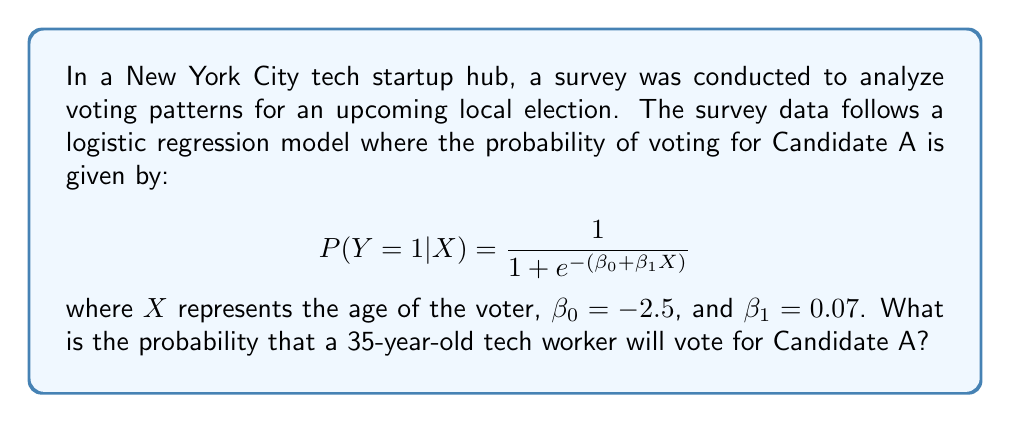Provide a solution to this math problem. To solve this problem, we'll follow these steps:

1. Identify the given information:
   $\beta_0 = -2.5$
   $\beta_1 = 0.07$
   $X = 35$ (age of the voter)

2. Substitute these values into the logistic regression equation:
   $$P(Y=1|X) = \frac{1}{1 + e^{-(\beta_0 + \beta_1X)}}$$
   $$P(Y=1|X=35) = \frac{1}{1 + e^{-(-2.5 + 0.07 \cdot 35)}}$$

3. Simplify the expression inside the exponential:
   $$P(Y=1|X=35) = \frac{1}{1 + e^{-(0.07 \cdot 35 - 2.5)}}$$
   $$P(Y=1|X=35) = \frac{1}{1 + e^{-(2.45 - 2.5)}}$$
   $$P(Y=1|X=35) = \frac{1}{1 + e^{-(-0.05)}}$$

4. Calculate the value of $e^{-(-0.05)}$:
   $$e^{-(-0.05)} = e^{0.05} \approx 1.0513$$

5. Substitute this value into the equation:
   $$P(Y=1|X=35) = \frac{1}{1 + 1.0513}$$

6. Perform the final calculation:
   $$P(Y=1|X=35) = \frac{1}{2.0513} \approx 0.4875$$
Answer: 0.4875 or 48.75% 